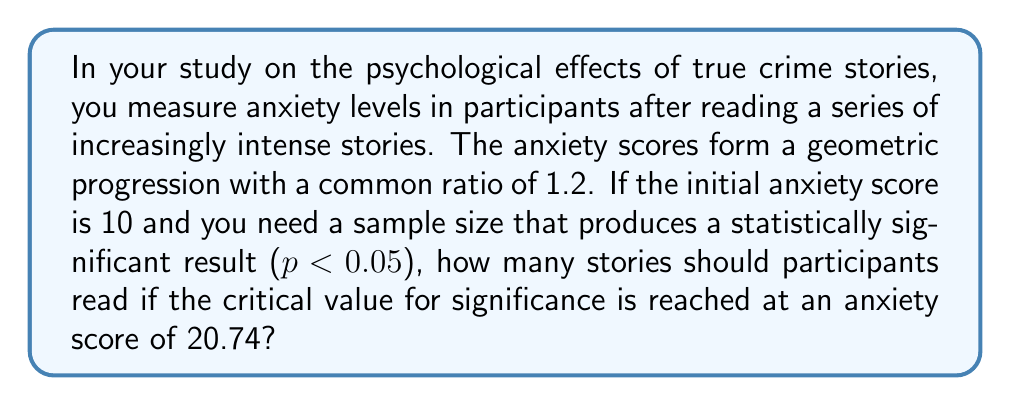Can you solve this math problem? Let's approach this step-by-step:

1) We have a geometric progression with:
   - Initial term $a = 10$
   - Common ratio $r = 1.2$
   - We need to find $n$ (number of terms) where the $n$th term $\geq 20.74$

2) The general term of a geometric progression is given by:
   $$a_n = ar^{n-1}$$

3) We need to solve:
   $$ar^{n-1} \geq 20.74$$

4) Substituting our values:
   $$10 \cdot 1.2^{n-1} \geq 20.74$$

5) Dividing both sides by 10:
   $$1.2^{n-1} \geq 2.074$$

6) Taking log base 1.2 on both sides:
   $$n-1 \geq \log_{1.2}(2.074)$$

7) Solving for n:
   $$n \geq \log_{1.2}(2.074) + 1$$

8) Using the change of base formula:
   $$n \geq \frac{\ln(2.074)}{\ln(1.2)} + 1$$

9) Calculating:
   $$n \geq 4.98 + 1 = 5.98$$

10) Since n must be a whole number and we need to reach or exceed 20.74, we round up.
Answer: 6 stories 